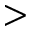Convert formula to latex. <formula><loc_0><loc_0><loc_500><loc_500>></formula> 